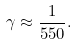Convert formula to latex. <formula><loc_0><loc_0><loc_500><loc_500>\gamma \approx \frac { 1 } { 5 5 0 } .</formula> 